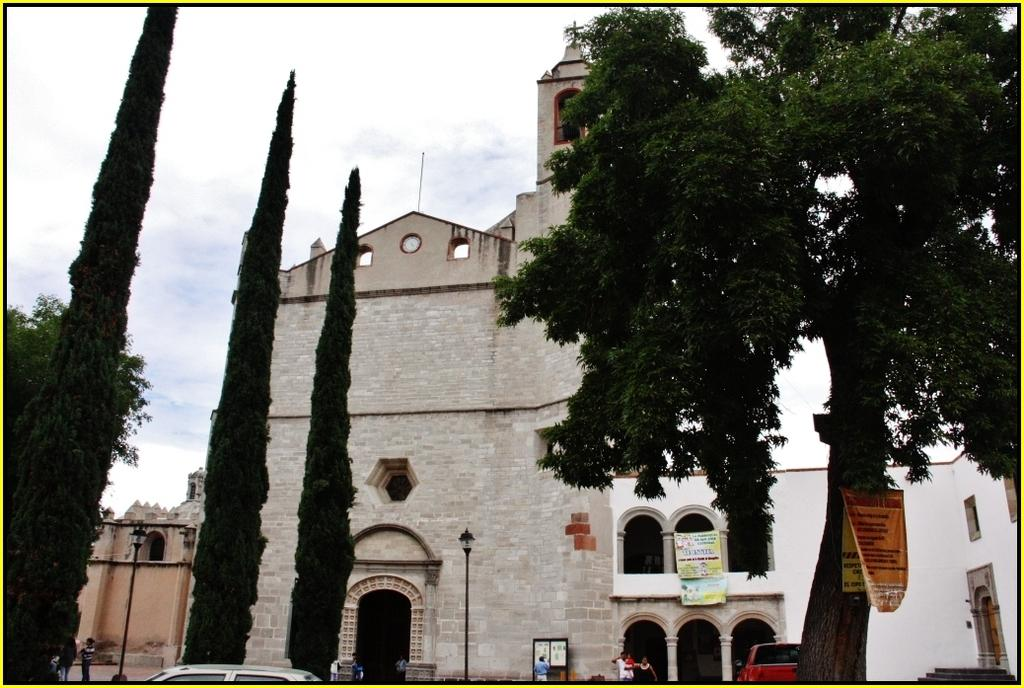What type of structures can be seen in the image? There are buildings in the image. What other objects can be seen in the image besides buildings? There are trees, poles, vehicles, people, lights, posters, and pillars in the image. What is visible in the background of the image? The sky is visible in the background of the image. What year is depicted on the canvas in the image? There is no canvas present in the image, and therefore no year can be identified. What type of alley can be seen in the image? There is no alley present in the image. 